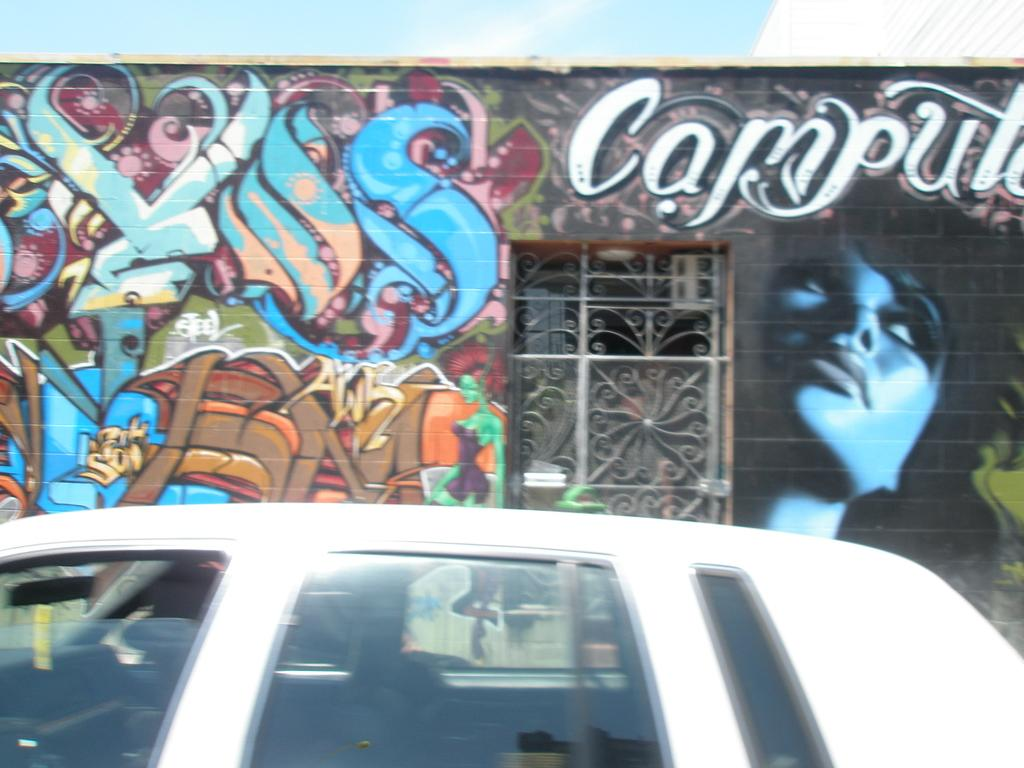What type of vehicle is in the image? There is a white car in the image. What is the background of the image? There is a spray paint wall in the image. Does the spray paint wall have any specific features? Yes, the spray paint wall has a window. How many cacti can be seen in the image? There are no cacti present in the image. What is the car thinking about in the image? Cars do not have thoughts or minds, so it is not possible to determine what the car might be thinking about. 